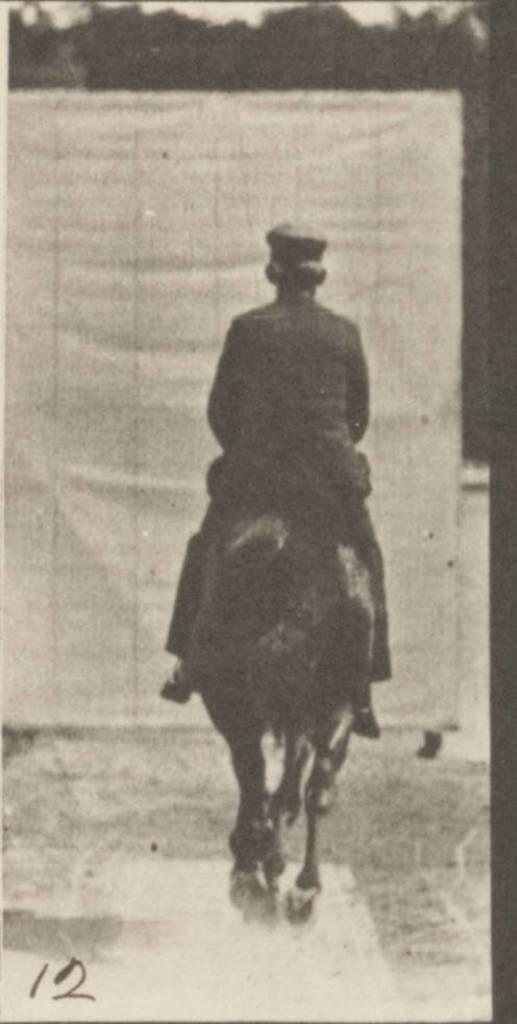In one or two sentences, can you explain what this image depicts? In the image there is a man riding on a horse on a mud road at the background there are trees. 